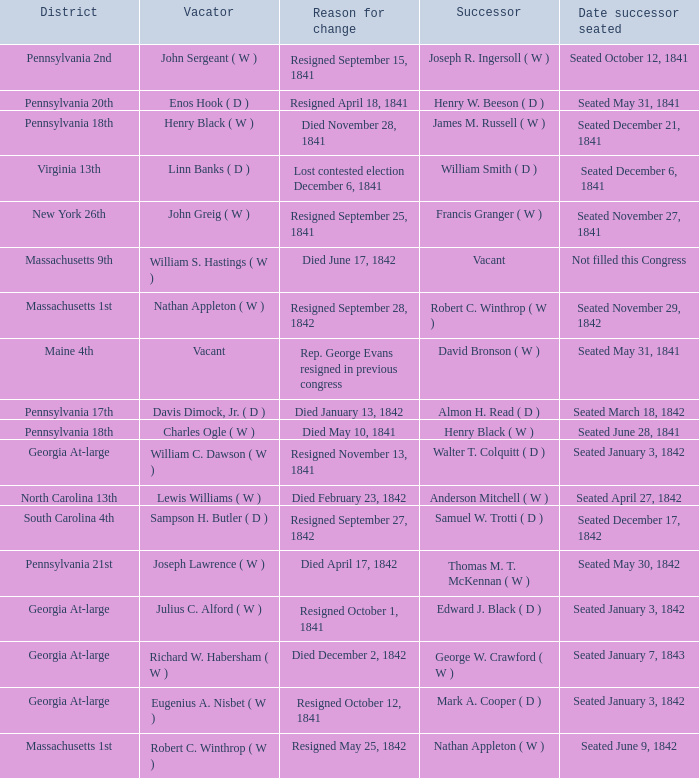Name the successor for north carolina 13th Anderson Mitchell ( W ). 